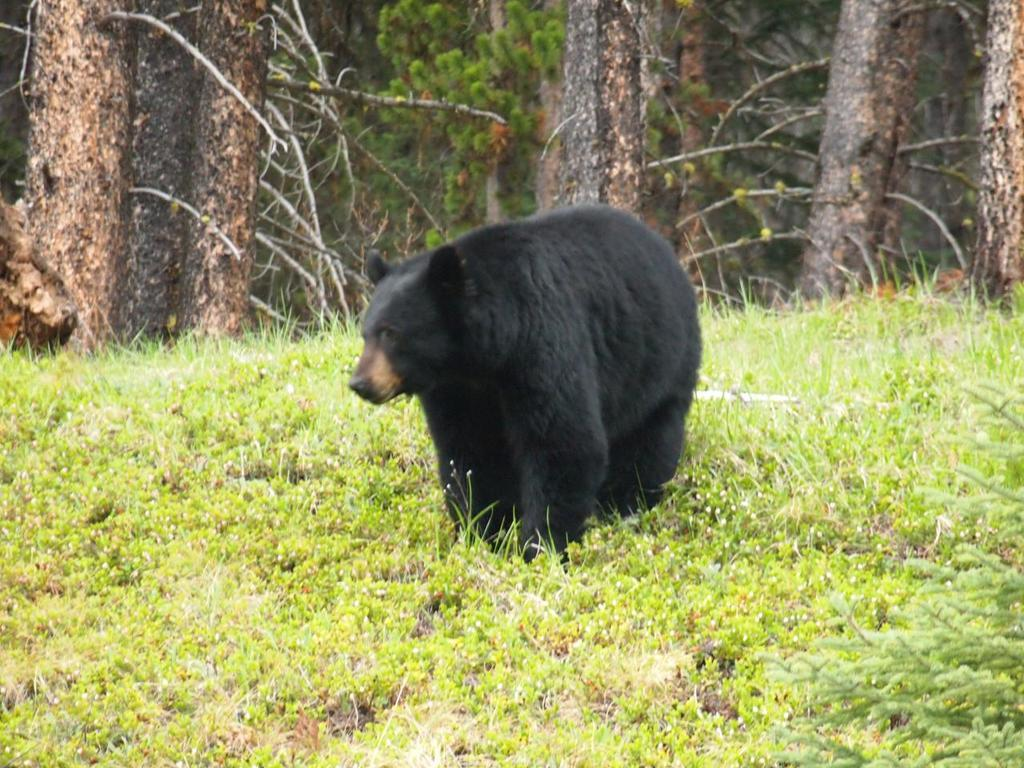What animal is present in the image? There is a bear in the image. Where is the bear located in the image? The bear is on the ground. What type of vegetation can be seen in the background of the image? There is grass in the background of the image. What other natural elements are visible in the background of the image? There are trees in the background of the image. What type of ship can be seen sailing in the background of the image? There is no ship present in the image; it features a bear on the ground with grass and trees in the background. 